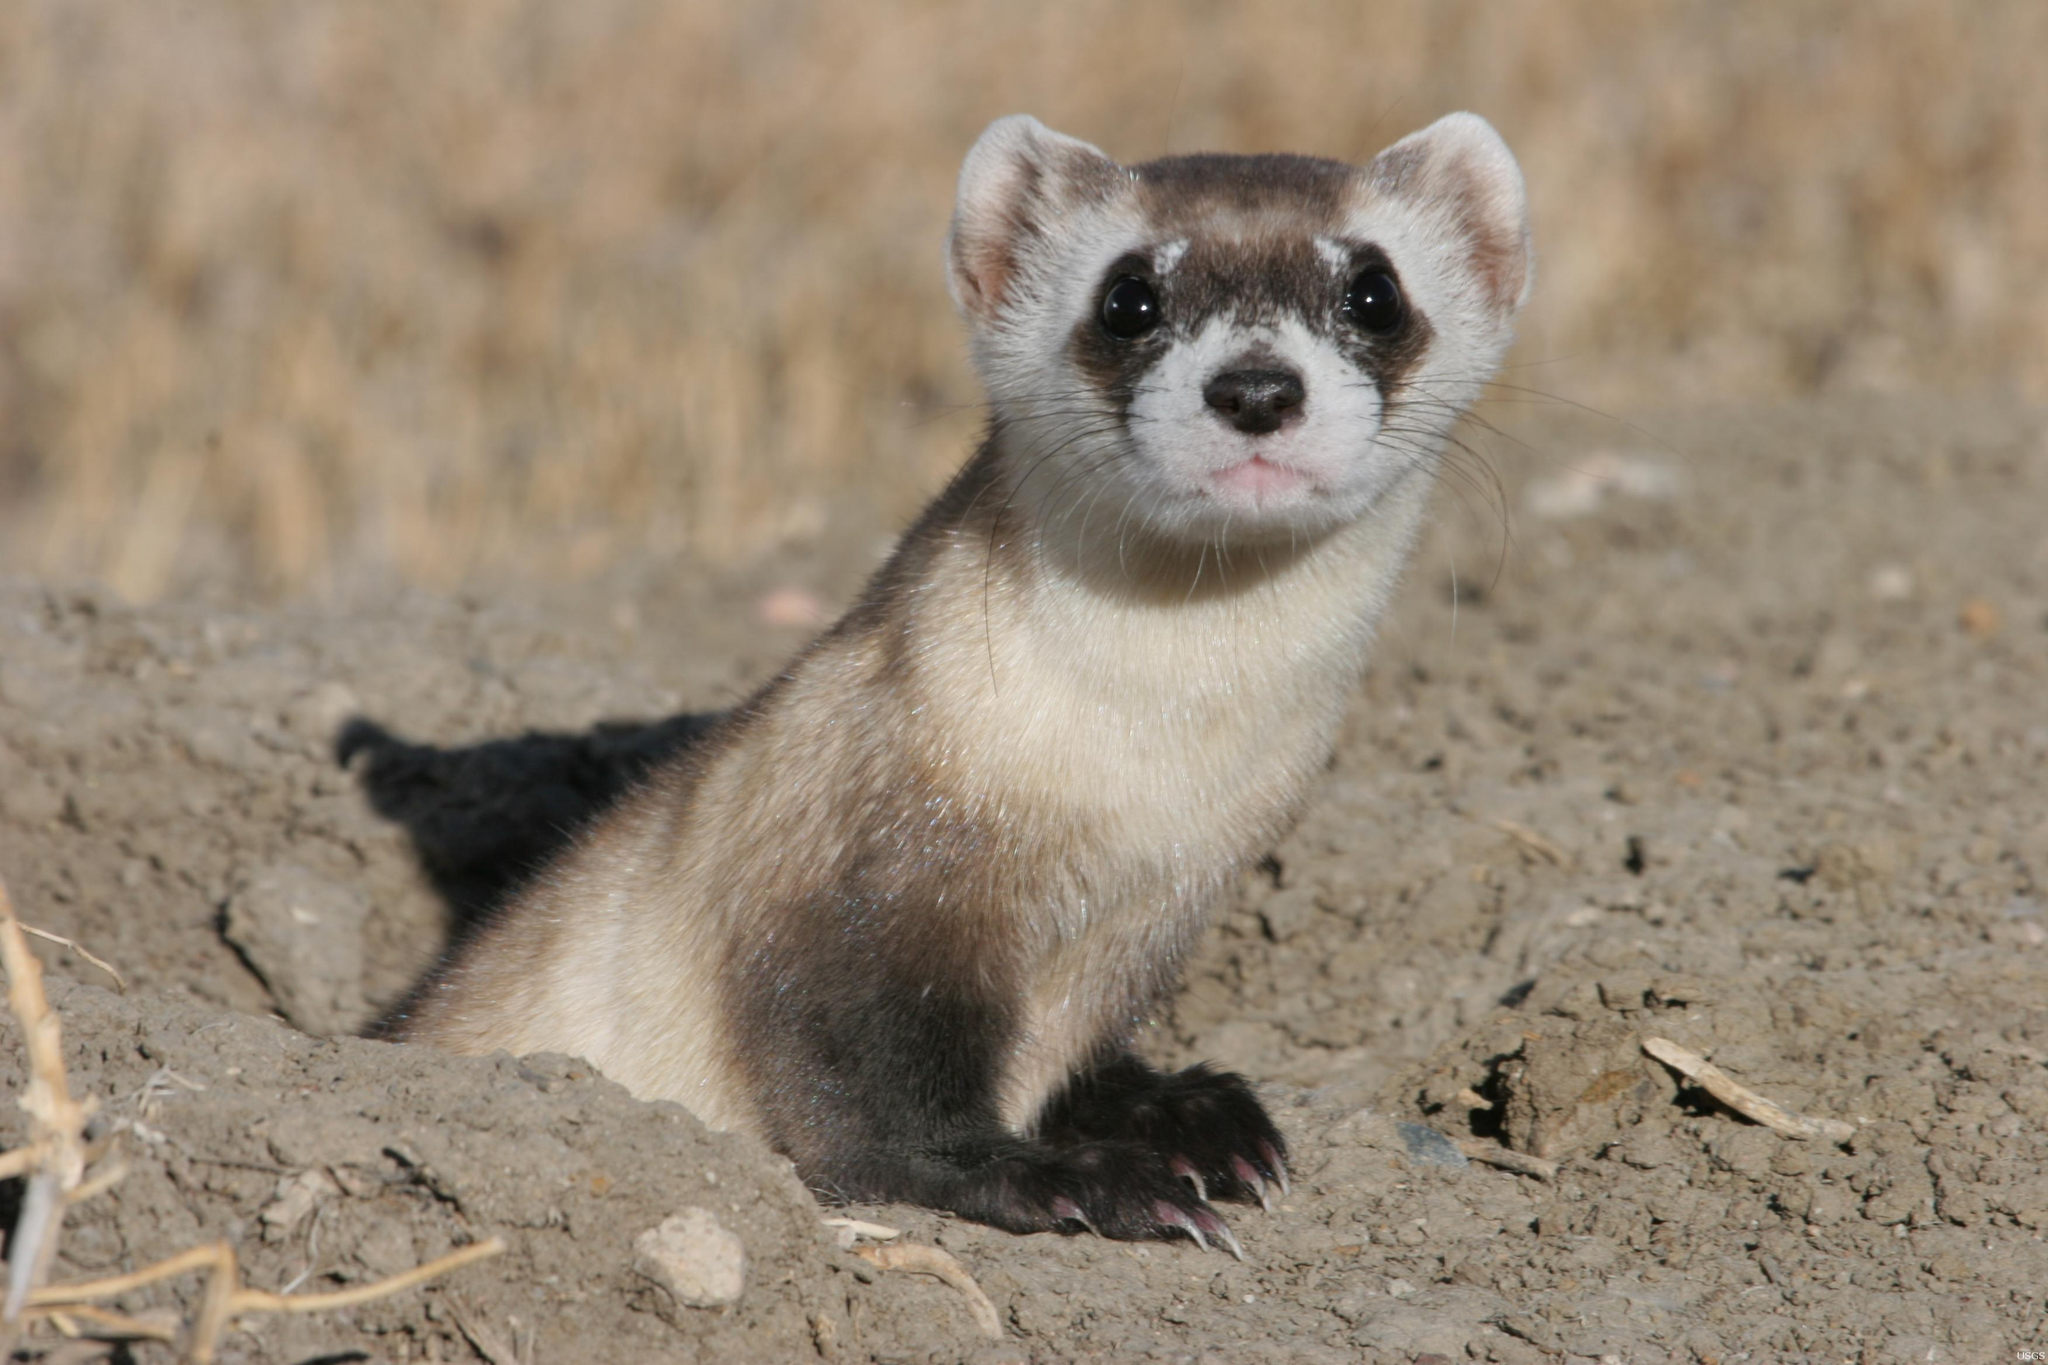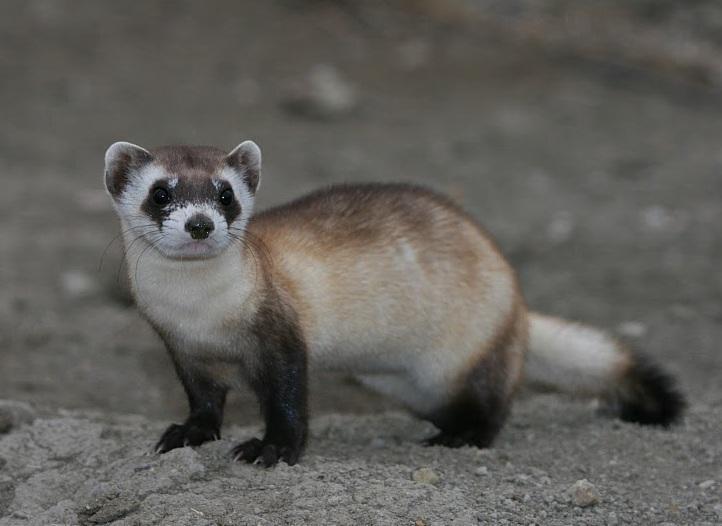The first image is the image on the left, the second image is the image on the right. Assess this claim about the two images: "In at least one image a Mustelid can be seen sticking its head out of a visible dirt hole.". Correct or not? Answer yes or no. Yes. The first image is the image on the left, the second image is the image on the right. For the images displayed, is the sentence "A ferret is partially inside of a hole." factually correct? Answer yes or no. Yes. 